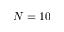<formula> <loc_0><loc_0><loc_500><loc_500>N = 1 0</formula> 